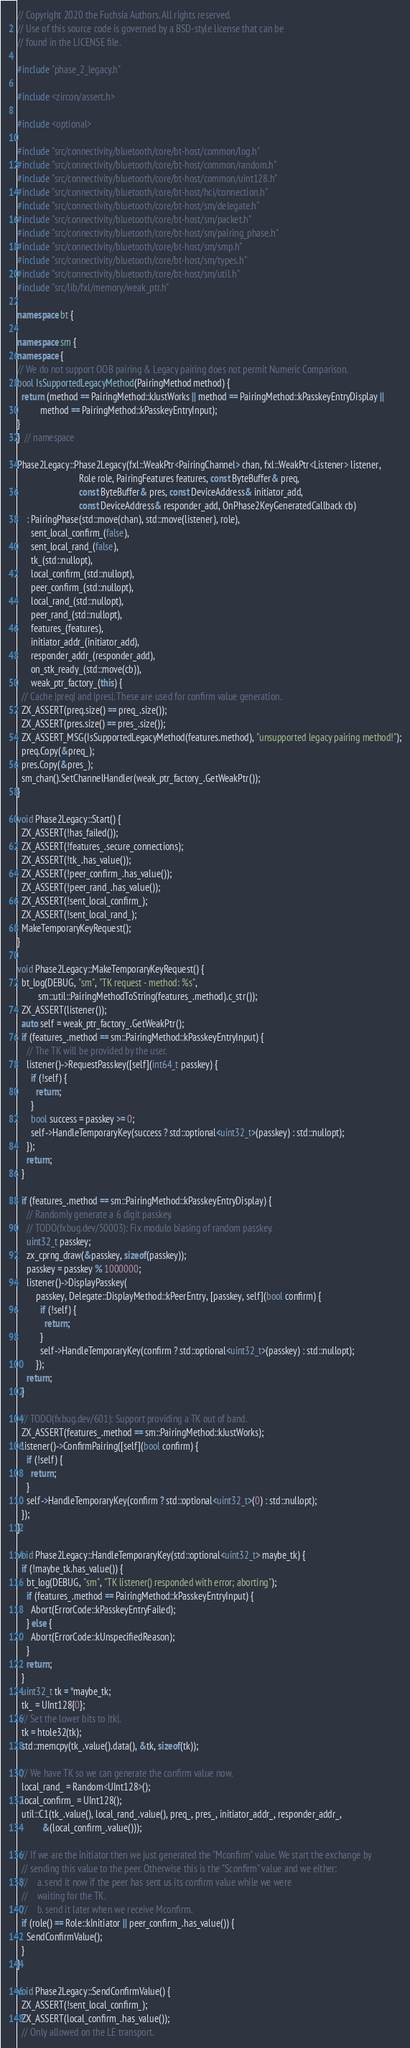Convert code to text. <code><loc_0><loc_0><loc_500><loc_500><_C++_>// Copyright 2020 the Fuchsia Authors. All rights reserved.
// Use of this source code is governed by a BSD-style license that can be
// found in the LICENSE file.

#include "phase_2_legacy.h"

#include <zircon/assert.h>

#include <optional>

#include "src/connectivity/bluetooth/core/bt-host/common/log.h"
#include "src/connectivity/bluetooth/core/bt-host/common/random.h"
#include "src/connectivity/bluetooth/core/bt-host/common/uint128.h"
#include "src/connectivity/bluetooth/core/bt-host/hci/connection.h"
#include "src/connectivity/bluetooth/core/bt-host/sm/delegate.h"
#include "src/connectivity/bluetooth/core/bt-host/sm/packet.h"
#include "src/connectivity/bluetooth/core/bt-host/sm/pairing_phase.h"
#include "src/connectivity/bluetooth/core/bt-host/sm/smp.h"
#include "src/connectivity/bluetooth/core/bt-host/sm/types.h"
#include "src/connectivity/bluetooth/core/bt-host/sm/util.h"
#include "src/lib/fxl/memory/weak_ptr.h"

namespace bt {

namespace sm {
namespace {
// We do not support OOB pairing & Legacy pairing does not permit Numeric Comparison.
bool IsSupportedLegacyMethod(PairingMethod method) {
  return (method == PairingMethod::kJustWorks || method == PairingMethod::kPasskeyEntryDisplay ||
          method == PairingMethod::kPasskeyEntryInput);
}
}  // namespace

Phase2Legacy::Phase2Legacy(fxl::WeakPtr<PairingChannel> chan, fxl::WeakPtr<Listener> listener,
                           Role role, PairingFeatures features, const ByteBuffer& preq,
                           const ByteBuffer& pres, const DeviceAddress& initiator_add,
                           const DeviceAddress& responder_add, OnPhase2KeyGeneratedCallback cb)
    : PairingPhase(std::move(chan), std::move(listener), role),
      sent_local_confirm_(false),
      sent_local_rand_(false),
      tk_(std::nullopt),
      local_confirm_(std::nullopt),
      peer_confirm_(std::nullopt),
      local_rand_(std::nullopt),
      peer_rand_(std::nullopt),
      features_(features),
      initiator_addr_(initiator_add),
      responder_addr_(responder_add),
      on_stk_ready_(std::move(cb)),
      weak_ptr_factory_(this) {
  // Cache |preq| and |pres|. These are used for confirm value generation.
  ZX_ASSERT(preq.size() == preq_.size());
  ZX_ASSERT(pres.size() == pres_.size());
  ZX_ASSERT_MSG(IsSupportedLegacyMethod(features.method), "unsupported legacy pairing method!");
  preq.Copy(&preq_);
  pres.Copy(&pres_);
  sm_chan().SetChannelHandler(weak_ptr_factory_.GetWeakPtr());
}

void Phase2Legacy::Start() {
  ZX_ASSERT(!has_failed());
  ZX_ASSERT(!features_.secure_connections);
  ZX_ASSERT(!tk_.has_value());
  ZX_ASSERT(!peer_confirm_.has_value());
  ZX_ASSERT(!peer_rand_.has_value());
  ZX_ASSERT(!sent_local_confirm_);
  ZX_ASSERT(!sent_local_rand_);
  MakeTemporaryKeyRequest();
}

void Phase2Legacy::MakeTemporaryKeyRequest() {
  bt_log(DEBUG, "sm", "TK request - method: %s",
         sm::util::PairingMethodToString(features_.method).c_str());
  ZX_ASSERT(listener());
  auto self = weak_ptr_factory_.GetWeakPtr();
  if (features_.method == sm::PairingMethod::kPasskeyEntryInput) {
    // The TK will be provided by the user.
    listener()->RequestPasskey([self](int64_t passkey) {
      if (!self) {
        return;
      }
      bool success = passkey >= 0;
      self->HandleTemporaryKey(success ? std::optional<uint32_t>(passkey) : std::nullopt);
    });
    return;
  }

  if (features_.method == sm::PairingMethod::kPasskeyEntryDisplay) {
    // Randomly generate a 6 digit passkey.
    // TODO(fxbug.dev/50003): Fix modulo biasing of random passkey.
    uint32_t passkey;
    zx_cprng_draw(&passkey, sizeof(passkey));
    passkey = passkey % 1000000;
    listener()->DisplayPasskey(
        passkey, Delegate::DisplayMethod::kPeerEntry, [passkey, self](bool confirm) {
          if (!self) {
            return;
          }
          self->HandleTemporaryKey(confirm ? std::optional<uint32_t>(passkey) : std::nullopt);
        });
    return;
  }

  // TODO(fxbug.dev/601): Support providing a TK out of band.
  ZX_ASSERT(features_.method == sm::PairingMethod::kJustWorks);
  listener()->ConfirmPairing([self](bool confirm) {
    if (!self) {
      return;
    }
    self->HandleTemporaryKey(confirm ? std::optional<uint32_t>(0) : std::nullopt);
  });
}

void Phase2Legacy::HandleTemporaryKey(std::optional<uint32_t> maybe_tk) {
  if (!maybe_tk.has_value()) {
    bt_log(DEBUG, "sm", "TK listener() responded with error; aborting");
    if (features_.method == PairingMethod::kPasskeyEntryInput) {
      Abort(ErrorCode::kPasskeyEntryFailed);
    } else {
      Abort(ErrorCode::kUnspecifiedReason);
    }
    return;
  }
  uint32_t tk = *maybe_tk;
  tk_ = UInt128{0};
  // Set the lower bits to |tk|.
  tk = htole32(tk);
  std::memcpy(tk_.value().data(), &tk, sizeof(tk));

  // We have TK so we can generate the confirm value now.
  local_rand_ = Random<UInt128>();
  local_confirm_ = UInt128();
  util::C1(tk_.value(), local_rand_.value(), preq_, pres_, initiator_addr_, responder_addr_,
           &(local_confirm_.value()));

  // If we are the initiator then we just generated the "Mconfirm" value. We start the exchange by
  // sending this value to the peer. Otherwise this is the "Sconfirm" value and we either:
  //    a. send it now if the peer has sent us its confirm value while we were
  //    waiting for the TK.
  //    b. send it later when we receive Mconfirm.
  if (role() == Role::kInitiator || peer_confirm_.has_value()) {
    SendConfirmValue();
  }
}

void Phase2Legacy::SendConfirmValue() {
  ZX_ASSERT(!sent_local_confirm_);
  ZX_ASSERT(local_confirm_.has_value());
  // Only allowed on the LE transport.</code> 